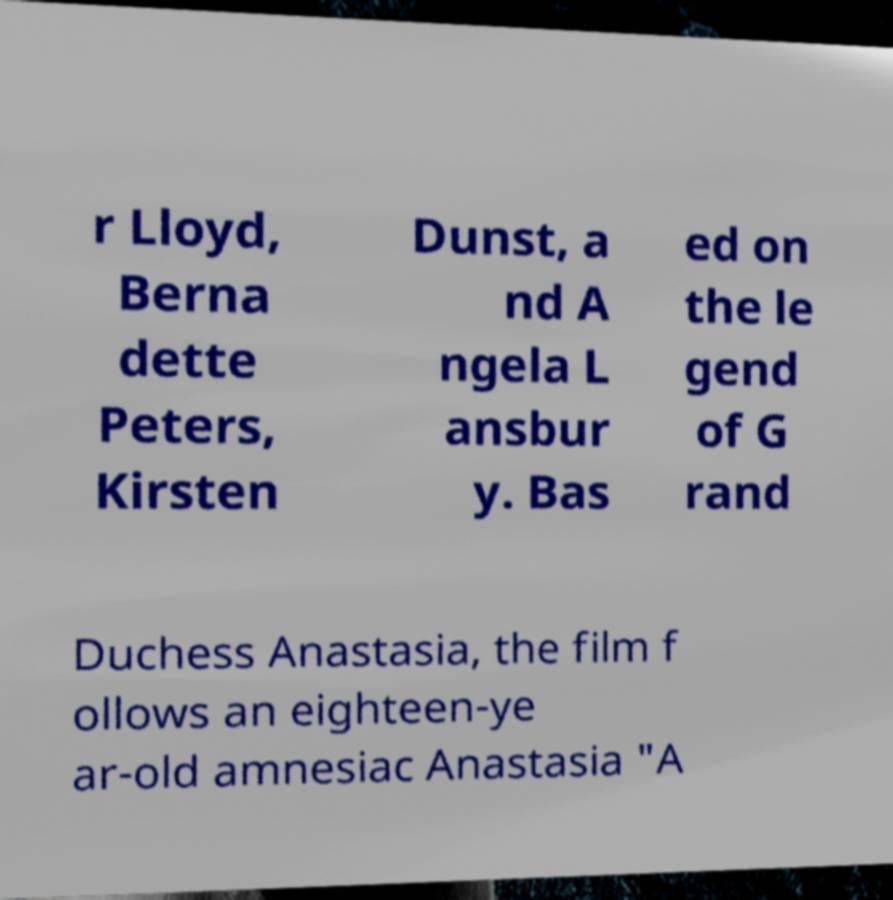Could you extract and type out the text from this image? r Lloyd, Berna dette Peters, Kirsten Dunst, a nd A ngela L ansbur y. Bas ed on the le gend of G rand Duchess Anastasia, the film f ollows an eighteen-ye ar-old amnesiac Anastasia "A 